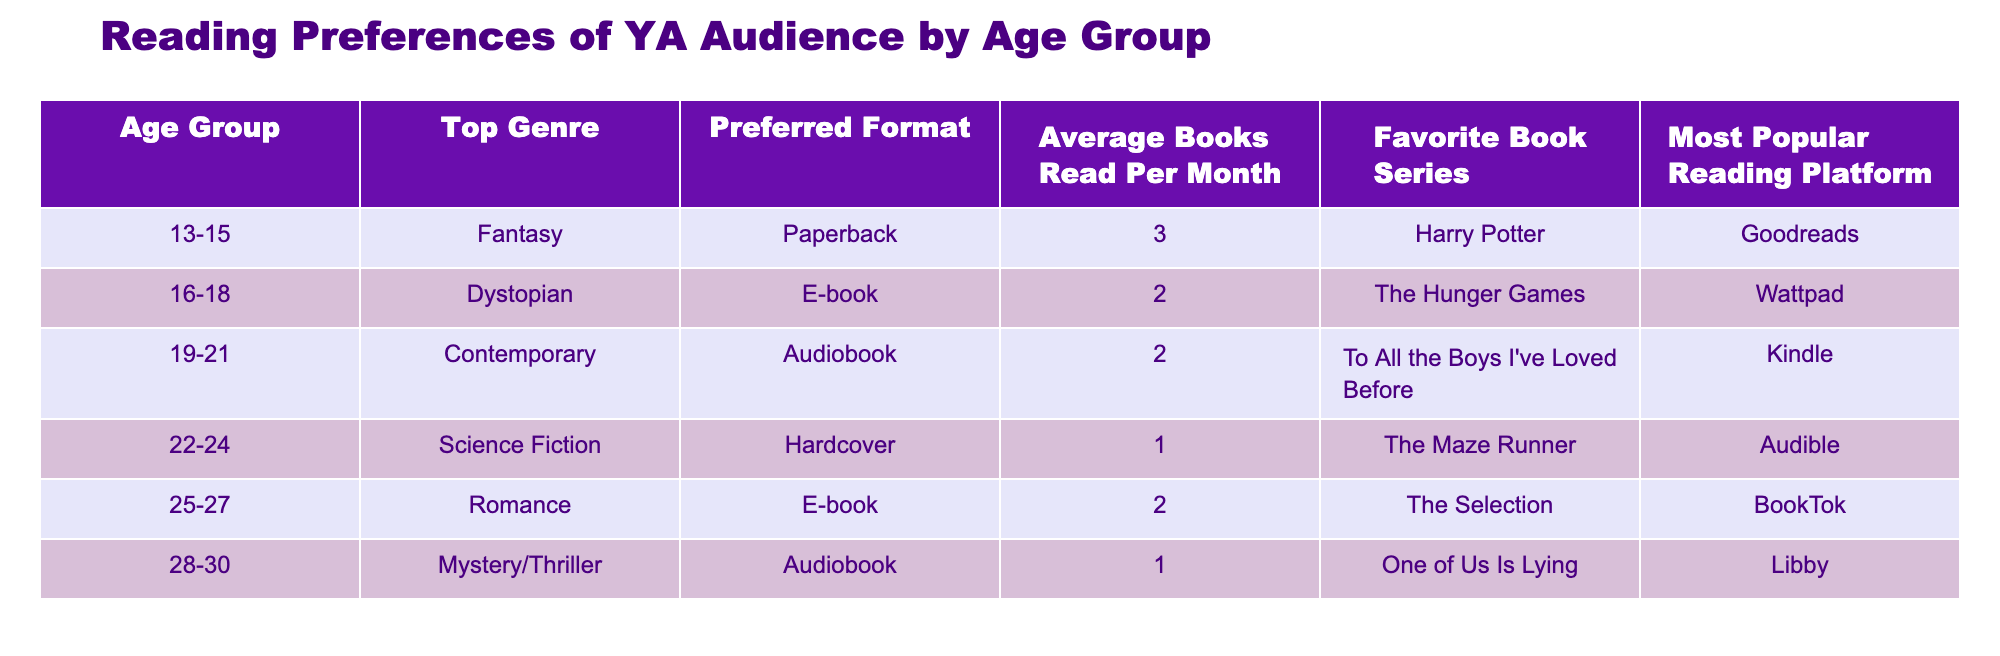What is the top genre for the age group 22-24? Referring to the table, I can see that for the age group 22-24, the top genre listed is Science Fiction.
Answer: Science Fiction How many average books does the age group 28-30 read per month? According to the table, the average books read per month by the age group 28-30 is 1.
Answer: 1 Which reading platform is most popular among the 19-21 age group? From the table, the most popular reading platform for the 19-21 age group is Kindle.
Answer: Kindle Is the preferred format for the 16-18 age group an E-book? The table indicates that the preferred format for the 16-18 age group is indeed E-book, making the statement true.
Answer: Yes Which age group has the highest average books read per month and what is that number? Looking through the table, the age group 13-15 reads an average of 3 books per month, which is higher than the other age groups. The second highest is age group 16-18 with 2 books per month.
Answer: 3 What is the favorite book series for the age group 25-27? According to the table, the favorite book series for the age group 25-27 is The Selection.
Answer: The Selection Do older age groups prefer audiobooks more than younger ones? By analyzing the data, younger age groups (13-15 and 16-18) prefer formats like Paperback and E-book, while older age groups (19-21, 22-24, and 28-30) prefer Audiobooks or Hardcover. Since the younger groups do not prefer audiobooks as much, the answer is no.
Answer: No What is the average number of books read per month for age groups 25-27 and 28-30 combined? To find the average for these age groups, I will sum the books read: 2 (age 25-27) + 1 (age 28-30) = 3. Then, dividing by the number of groups (2), we get an average of 3/2 = 1.5 books per month.
Answer: 1.5 Which genre is preferred by the age group that reads the most books? Since the age group 13-15 reads the most at an average of 3 books per month and their top genre is Fantasy, the answer is Fantasy.
Answer: Fantasy 